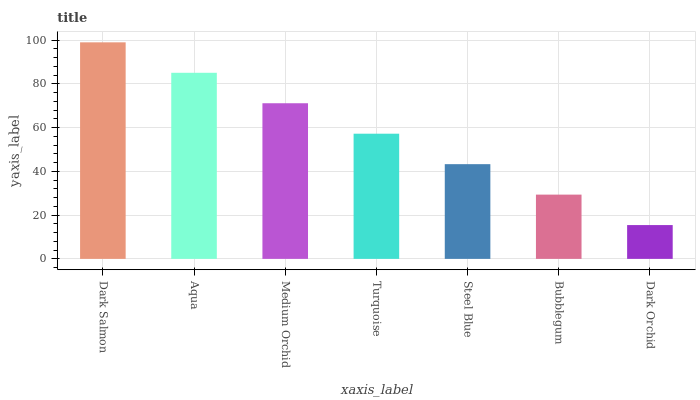Is Aqua the minimum?
Answer yes or no. No. Is Aqua the maximum?
Answer yes or no. No. Is Dark Salmon greater than Aqua?
Answer yes or no. Yes. Is Aqua less than Dark Salmon?
Answer yes or no. Yes. Is Aqua greater than Dark Salmon?
Answer yes or no. No. Is Dark Salmon less than Aqua?
Answer yes or no. No. Is Turquoise the high median?
Answer yes or no. Yes. Is Turquoise the low median?
Answer yes or no. Yes. Is Aqua the high median?
Answer yes or no. No. Is Dark Salmon the low median?
Answer yes or no. No. 